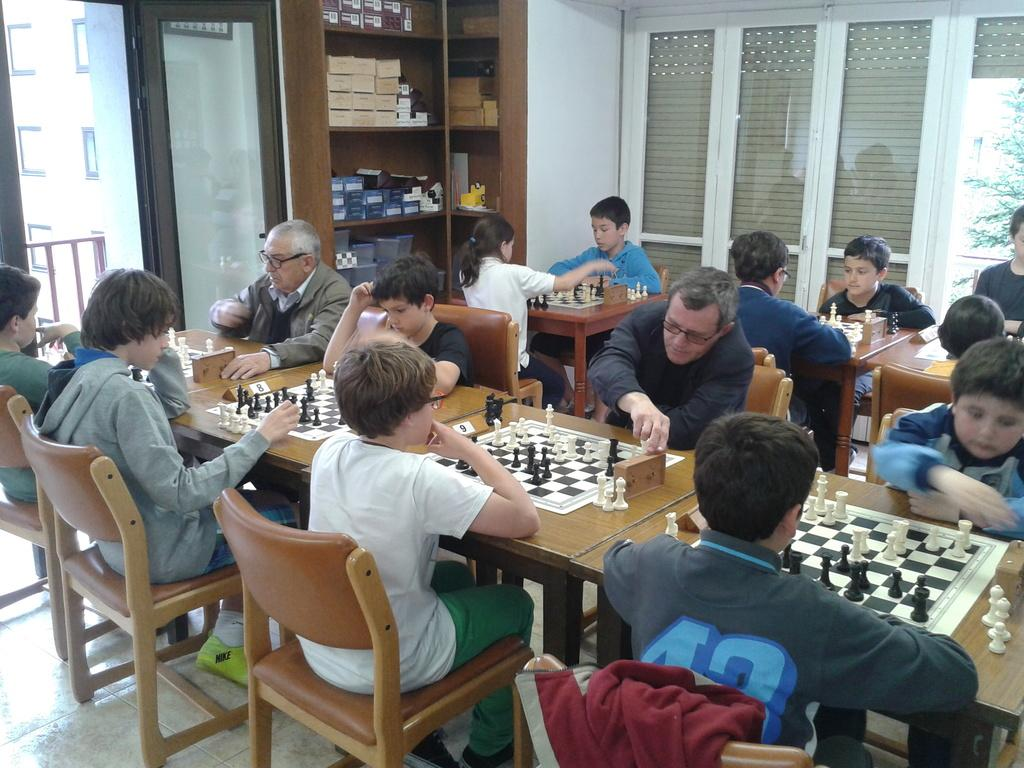What are the persons in the image doing? The persons in the image are sitting on chairs. What is on the table in the image? There are chess boards on the table. What is the background of the image made of? There is a wall in the image, which suggests the background is made of a solid material. What is the purpose of the rack in the image? The purpose of the rack in the image is not clear from the provided facts, but it could be used for storage or display. What is visible beneath the table and chairs in the image? There is a floor visible in the image. What type of knot can be seen in the image? There is no knot present in the image. 